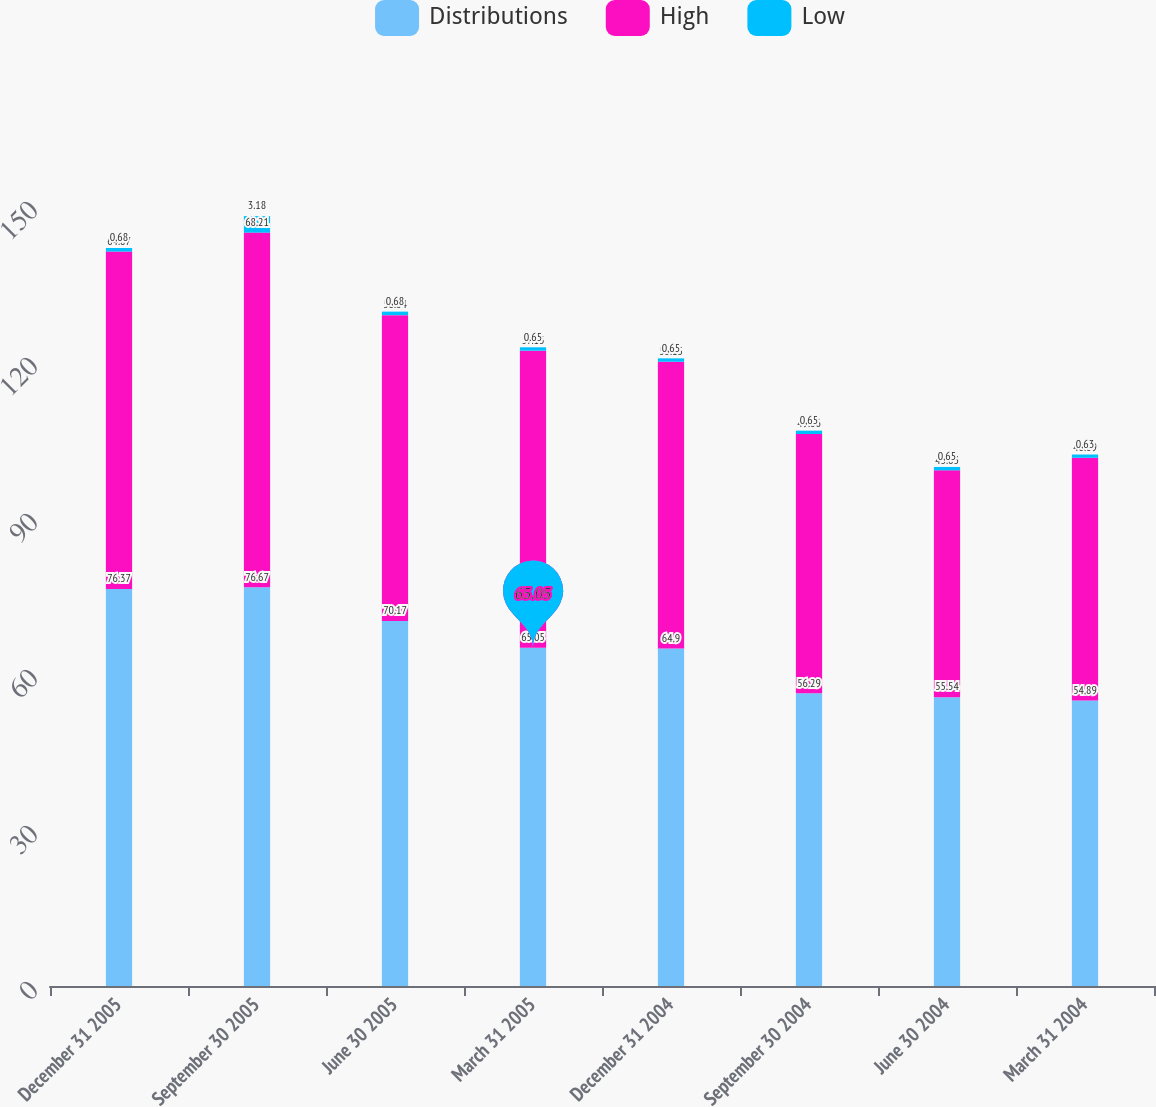Convert chart. <chart><loc_0><loc_0><loc_500><loc_500><stacked_bar_chart><ecel><fcel>December 31 2005<fcel>September 30 2005<fcel>June 30 2005<fcel>March 31 2005<fcel>December 31 2004<fcel>September 30 2004<fcel>June 30 2004<fcel>March 31 2004<nl><fcel>Distributions<fcel>76.37<fcel>76.67<fcel>70.17<fcel>65.05<fcel>64.9<fcel>56.29<fcel>55.54<fcel>54.89<nl><fcel>High<fcel>64.87<fcel>68.21<fcel>58.84<fcel>57.13<fcel>55.15<fcel>49.86<fcel>43.63<fcel>46.69<nl><fcel>Low<fcel>0.68<fcel>3.18<fcel>0.68<fcel>0.65<fcel>0.65<fcel>0.65<fcel>0.65<fcel>0.63<nl></chart> 